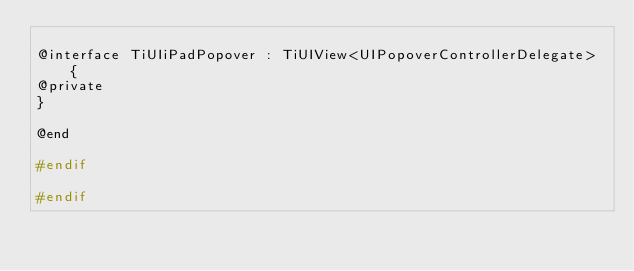<code> <loc_0><loc_0><loc_500><loc_500><_C_>
@interface TiUIiPadPopover : TiUIView<UIPopoverControllerDelegate> {
@private
}

@end

#endif

#endif</code> 